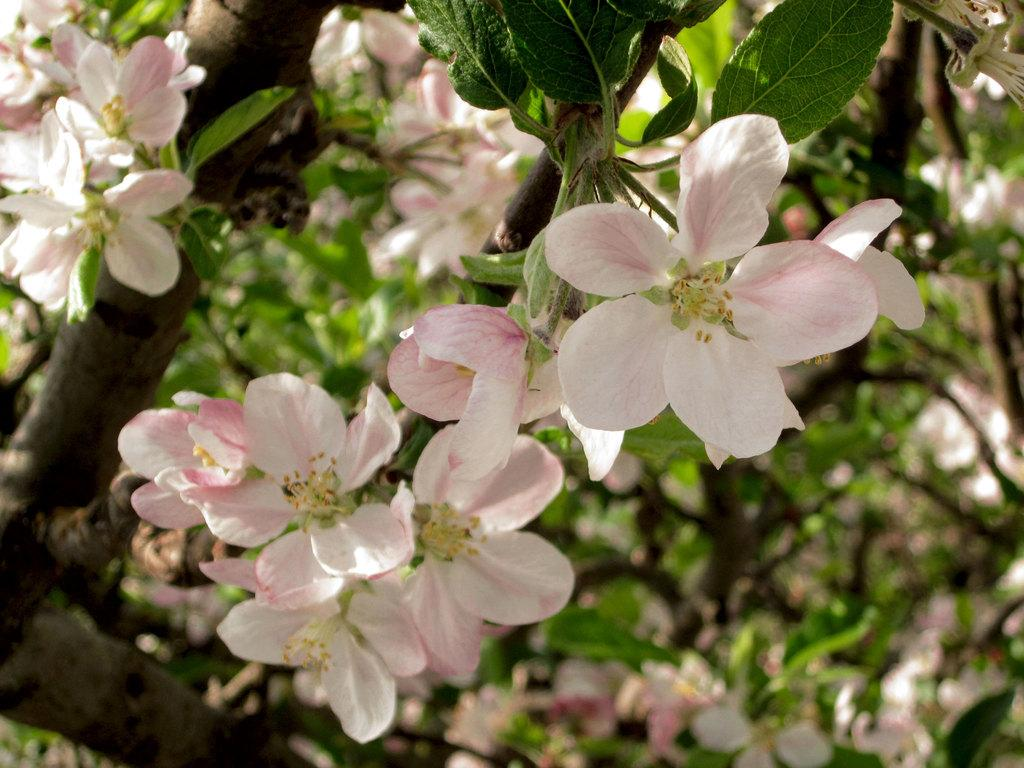What is the main subject of the image? The main subject of the image is a branch of a tree. What can be seen on the branch? There are flowers and green leaves on the branch. What type of lipstick is being applied to the branch in the image? There is no lipstick or any indication of applying makeup in the image; it features a branch with flowers and green leaves. 